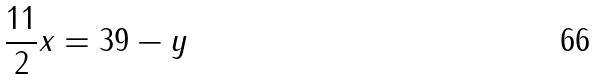<formula> <loc_0><loc_0><loc_500><loc_500>\frac { 1 1 } { 2 } x = 3 9 - y</formula> 